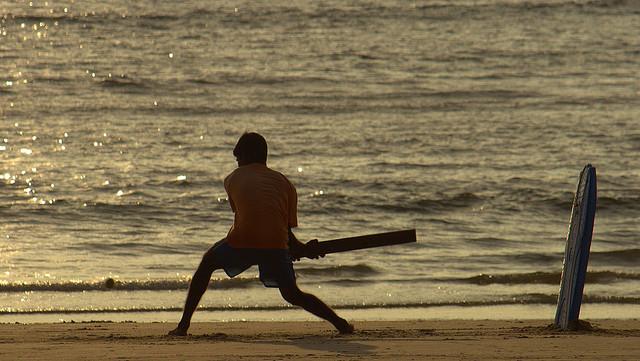How old is this boy?
Keep it brief. 13. Is the water calm?
Quick response, please. Yes. Is the boy holding a bat?
Keep it brief. No. What is the man doing?
Be succinct. Hitting ball. Is the boy near water?
Quick response, please. Yes. 